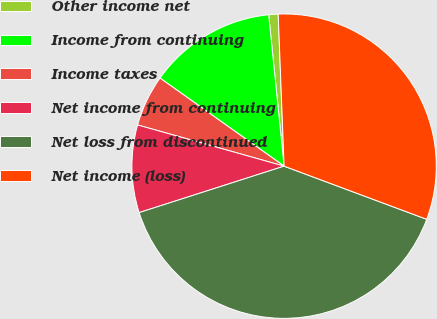Convert chart to OTSL. <chart><loc_0><loc_0><loc_500><loc_500><pie_chart><fcel>Other income net<fcel>Income from continuing<fcel>Income taxes<fcel>Net income from continuing<fcel>Net loss from discontinued<fcel>Net income (loss)<nl><fcel>1.0%<fcel>13.56%<fcel>5.46%<fcel>9.3%<fcel>39.39%<fcel>31.3%<nl></chart> 